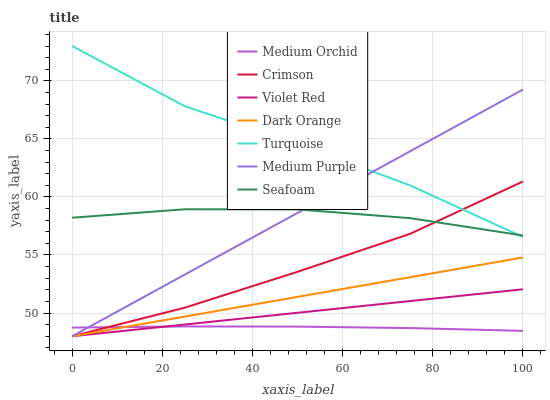Does Medium Orchid have the minimum area under the curve?
Answer yes or no. Yes. Does Turquoise have the maximum area under the curve?
Answer yes or no. Yes. Does Violet Red have the minimum area under the curve?
Answer yes or no. No. Does Violet Red have the maximum area under the curve?
Answer yes or no. No. Is Dark Orange the smoothest?
Answer yes or no. Yes. Is Turquoise the roughest?
Answer yes or no. Yes. Is Medium Orchid the smoothest?
Answer yes or no. No. Is Medium Orchid the roughest?
Answer yes or no. No. Does Dark Orange have the lowest value?
Answer yes or no. Yes. Does Medium Orchid have the lowest value?
Answer yes or no. No. Does Turquoise have the highest value?
Answer yes or no. Yes. Does Violet Red have the highest value?
Answer yes or no. No. Is Dark Orange less than Turquoise?
Answer yes or no. Yes. Is Turquoise greater than Dark Orange?
Answer yes or no. Yes. Does Crimson intersect Seafoam?
Answer yes or no. Yes. Is Crimson less than Seafoam?
Answer yes or no. No. Is Crimson greater than Seafoam?
Answer yes or no. No. Does Dark Orange intersect Turquoise?
Answer yes or no. No. 